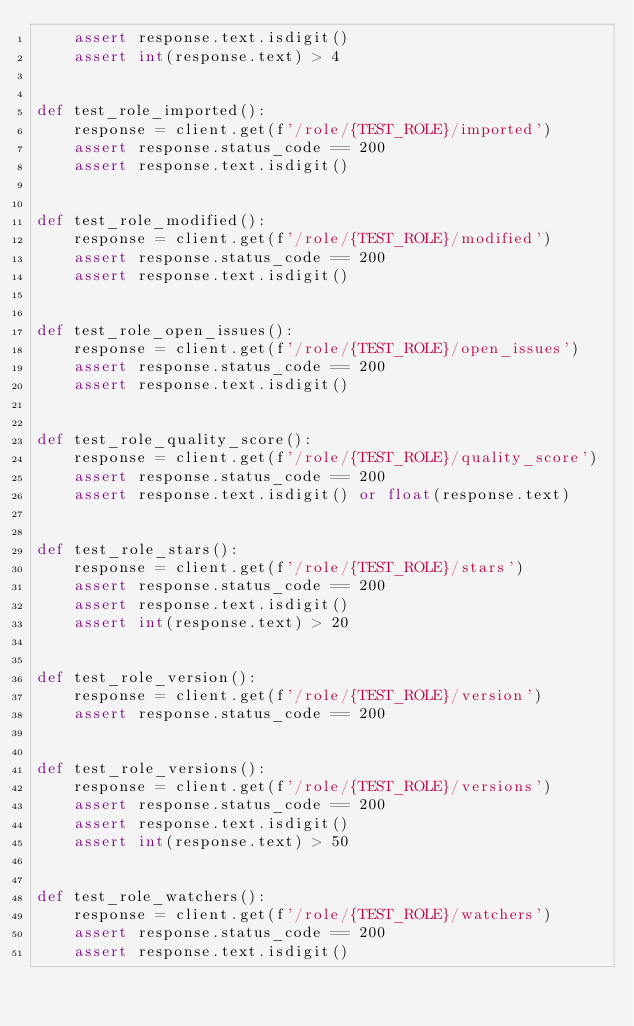Convert code to text. <code><loc_0><loc_0><loc_500><loc_500><_Python_>    assert response.text.isdigit()
    assert int(response.text) > 4


def test_role_imported():
    response = client.get(f'/role/{TEST_ROLE}/imported')
    assert response.status_code == 200
    assert response.text.isdigit()


def test_role_modified():
    response = client.get(f'/role/{TEST_ROLE}/modified')
    assert response.status_code == 200
    assert response.text.isdigit()


def test_role_open_issues():
    response = client.get(f'/role/{TEST_ROLE}/open_issues')
    assert response.status_code == 200
    assert response.text.isdigit()


def test_role_quality_score():
    response = client.get(f'/role/{TEST_ROLE}/quality_score')
    assert response.status_code == 200
    assert response.text.isdigit() or float(response.text)


def test_role_stars():
    response = client.get(f'/role/{TEST_ROLE}/stars')
    assert response.status_code == 200
    assert response.text.isdigit()
    assert int(response.text) > 20


def test_role_version():
    response = client.get(f'/role/{TEST_ROLE}/version')
    assert response.status_code == 200


def test_role_versions():
    response = client.get(f'/role/{TEST_ROLE}/versions')
    assert response.status_code == 200
    assert response.text.isdigit()
    assert int(response.text) > 50


def test_role_watchers():
    response = client.get(f'/role/{TEST_ROLE}/watchers')
    assert response.status_code == 200
    assert response.text.isdigit()
</code> 